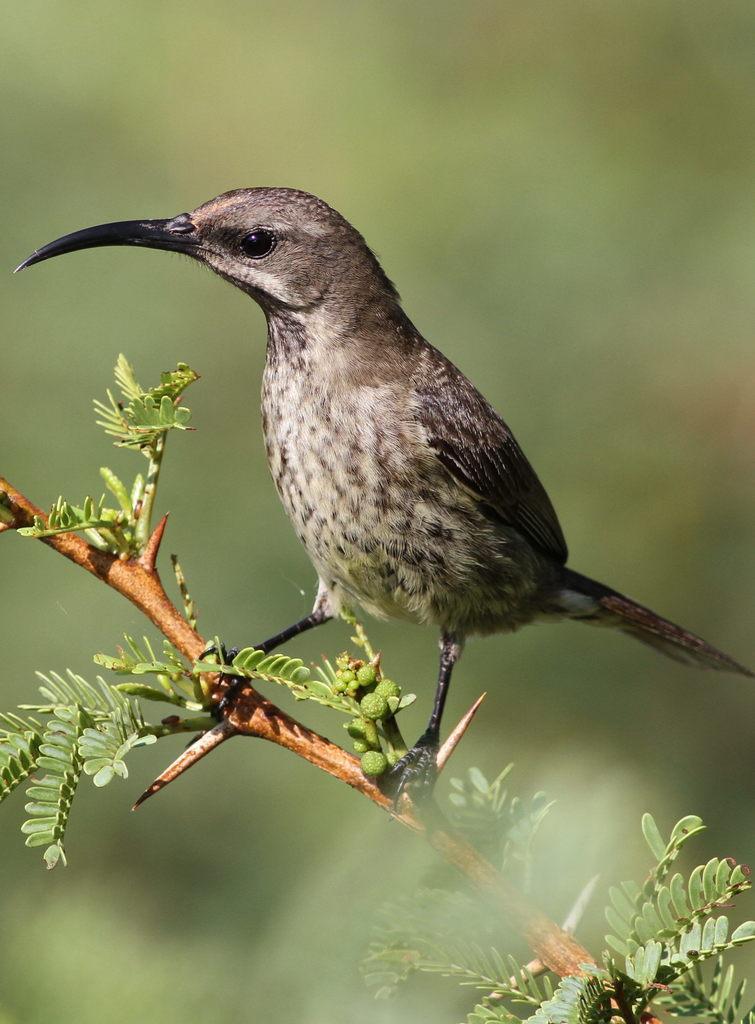Can you describe this image briefly? In the foreground of this image, there is a bird with long beak standing on the stem of a plant and in the background of this image is blurred. 